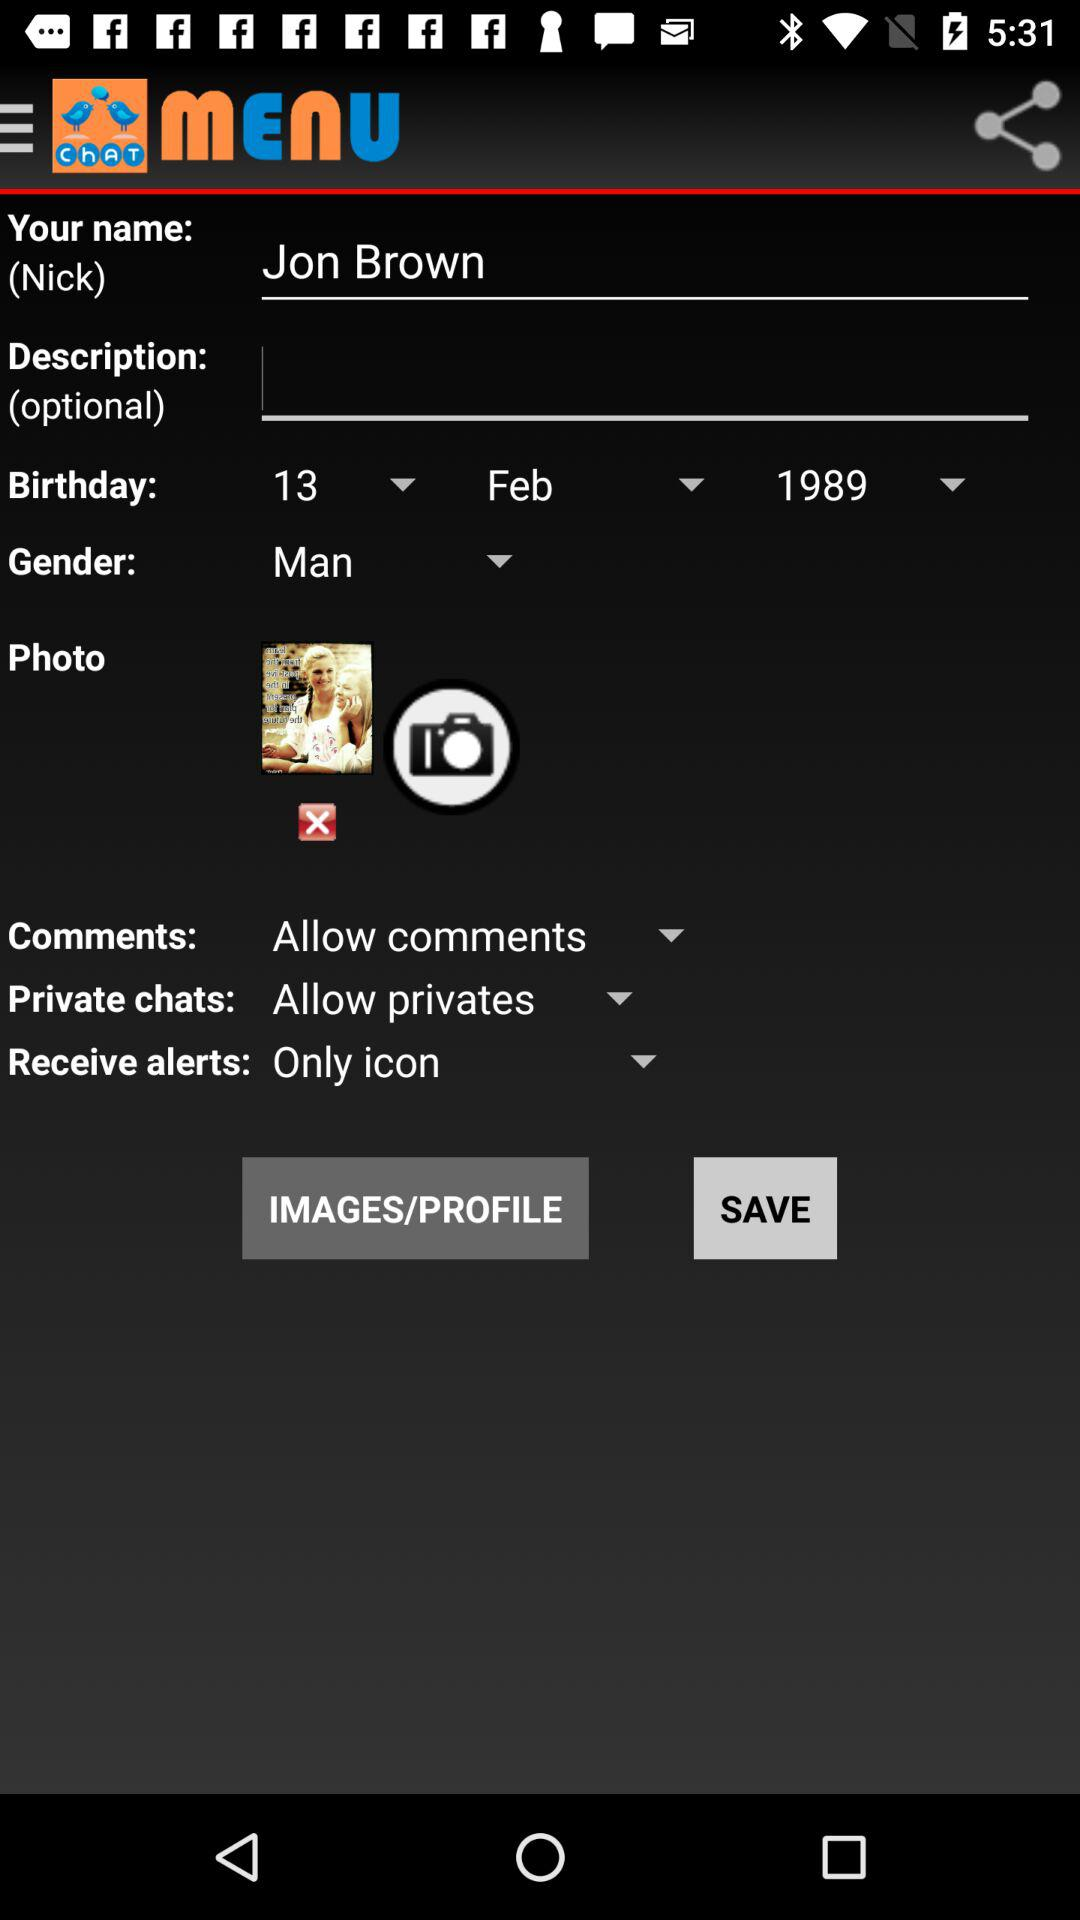What is the setting for private chats? The setting is "Allow privates". 